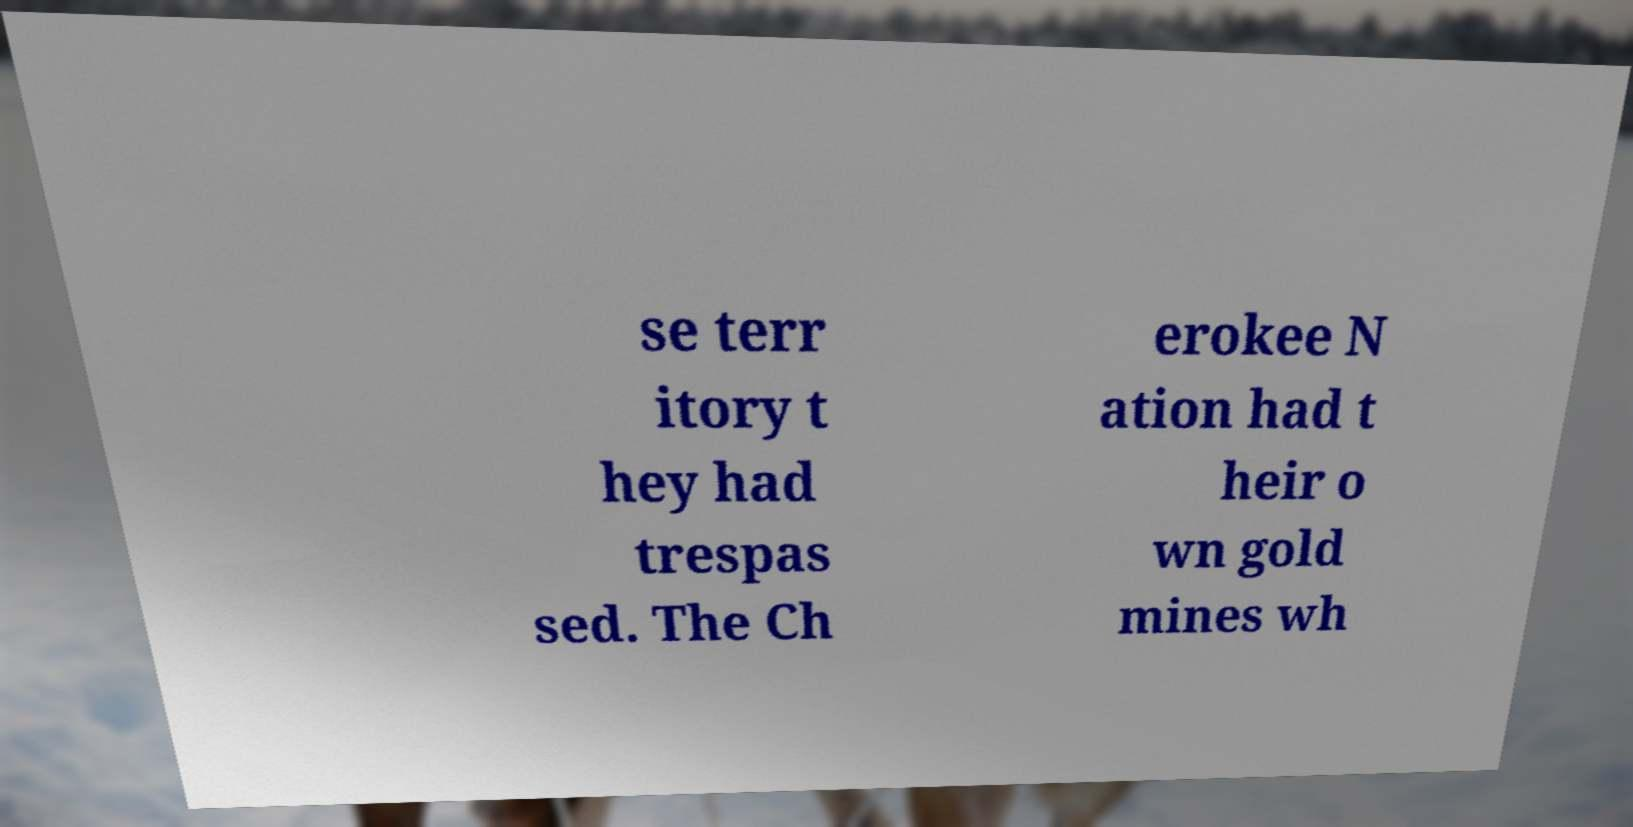Could you extract and type out the text from this image? se terr itory t hey had trespas sed. The Ch erokee N ation had t heir o wn gold mines wh 